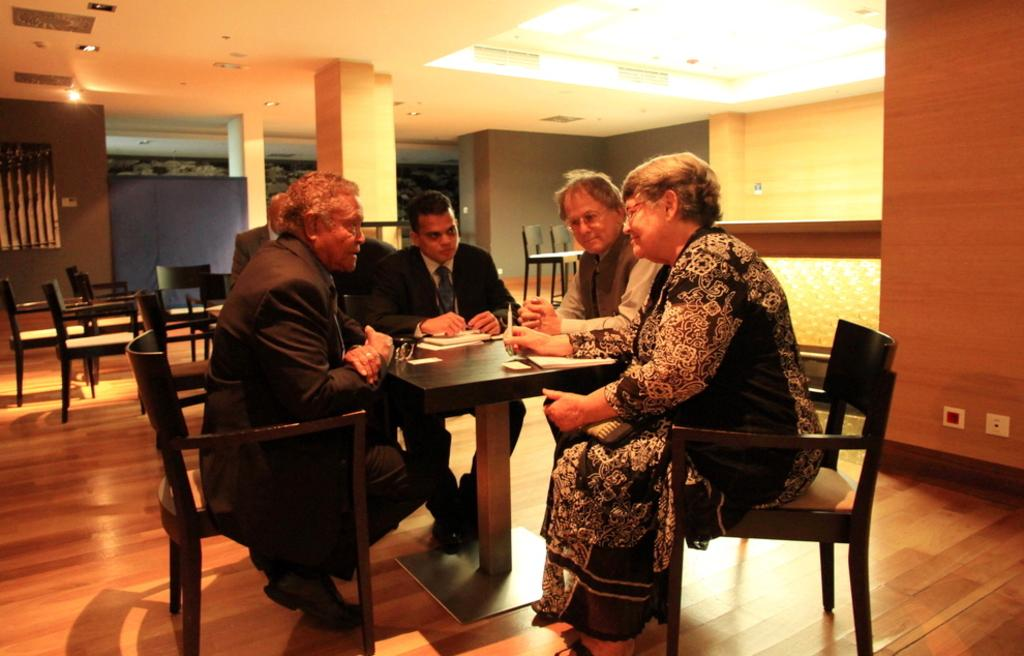What are the people in the image doing? The people in the image are sitting on chairs. Can you describe the chairs in the image? There are chairs visible in the image, both in the foreground and background. What direction is the square facing in the image? There is no square present in the image, so it cannot be determined which direction it would be facing. 